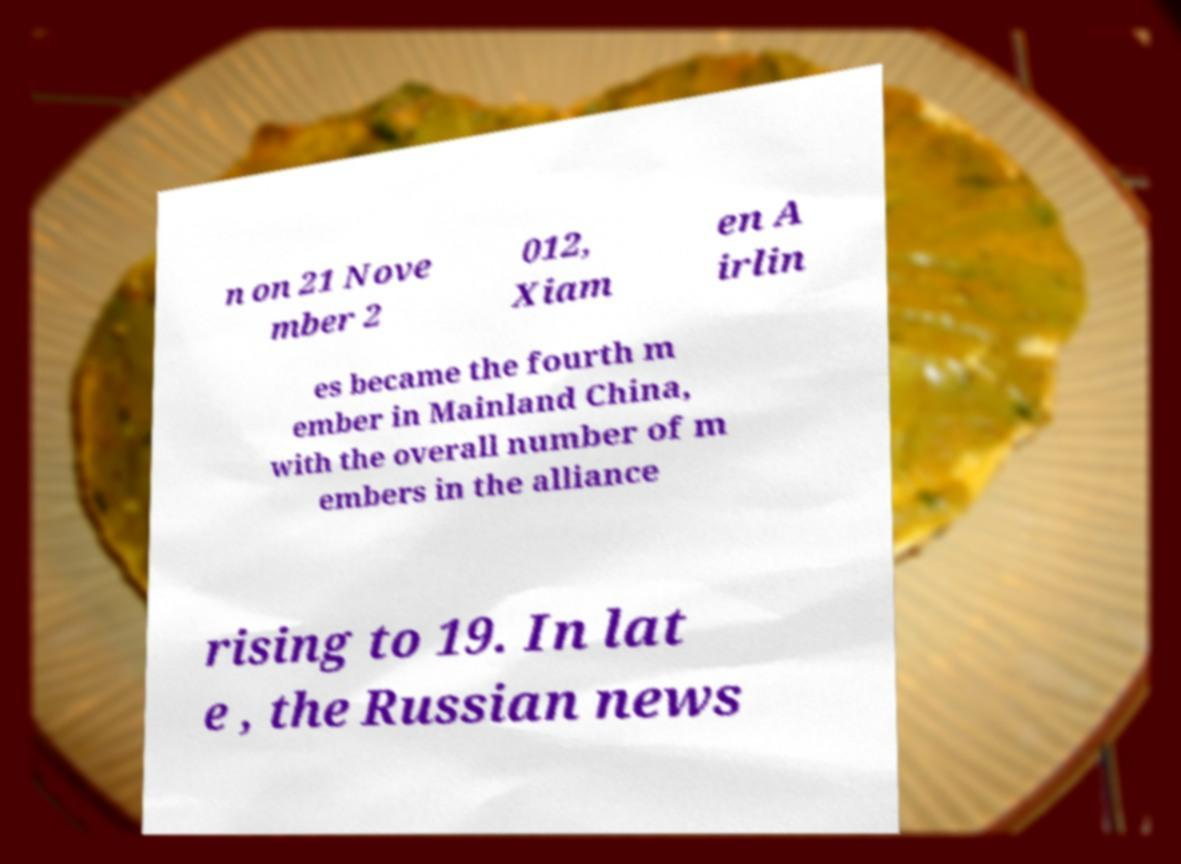Please identify and transcribe the text found in this image. n on 21 Nove mber 2 012, Xiam en A irlin es became the fourth m ember in Mainland China, with the overall number of m embers in the alliance rising to 19. In lat e , the Russian news 